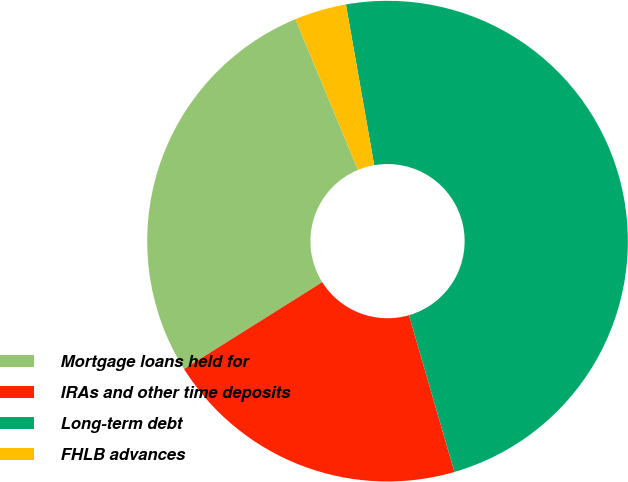Convert chart to OTSL. <chart><loc_0><loc_0><loc_500><loc_500><pie_chart><fcel>Mortgage loans held for<fcel>IRAs and other time deposits<fcel>Long-term debt<fcel>FHLB advances<nl><fcel>27.67%<fcel>20.56%<fcel>48.28%<fcel>3.49%<nl></chart> 